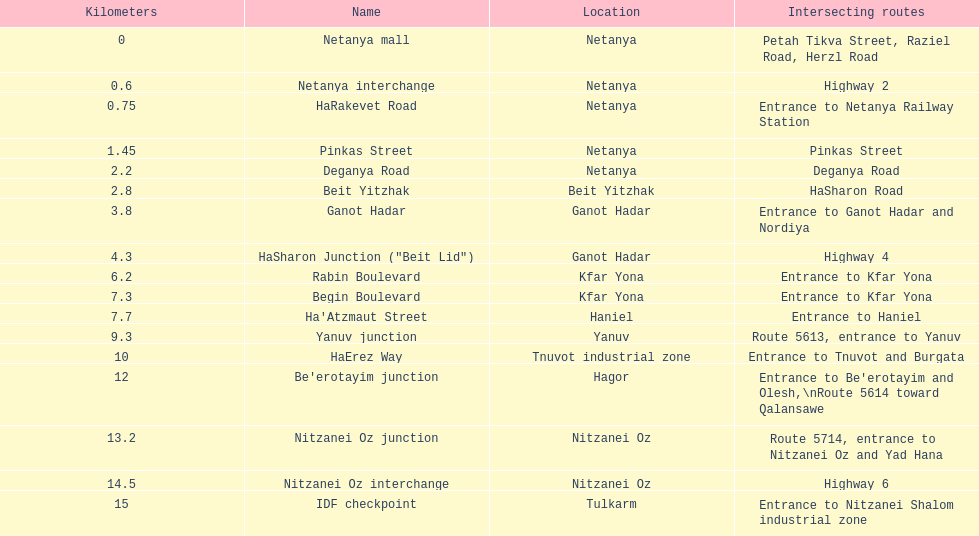In which area does the intersecting route coincide with rabin boulevard? Begin Boulevard. 